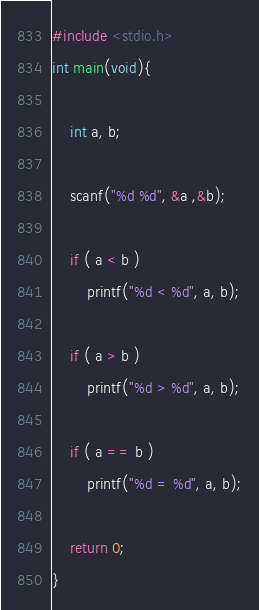<code> <loc_0><loc_0><loc_500><loc_500><_C_>#include <stdio.h>
int main(void){
    
    int a, b;
    
    scanf("%d %d", &a ,&b);
    
    if ( a < b )
        printf("%d < %d", a, b);
    
    if ( a > b )
        printf("%d > %d", a, b);
    
    if ( a == b )
        printf("%d = %d", a, b);
    
    return 0;
}</code> 